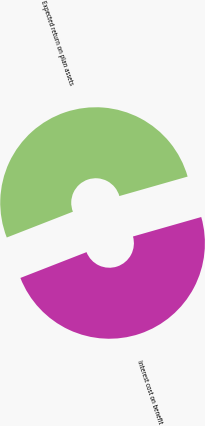Convert chart to OTSL. <chart><loc_0><loc_0><loc_500><loc_500><pie_chart><fcel>Interest cost on benefit<fcel>Expected return on plan assets<nl><fcel>48.5%<fcel>51.5%<nl></chart> 